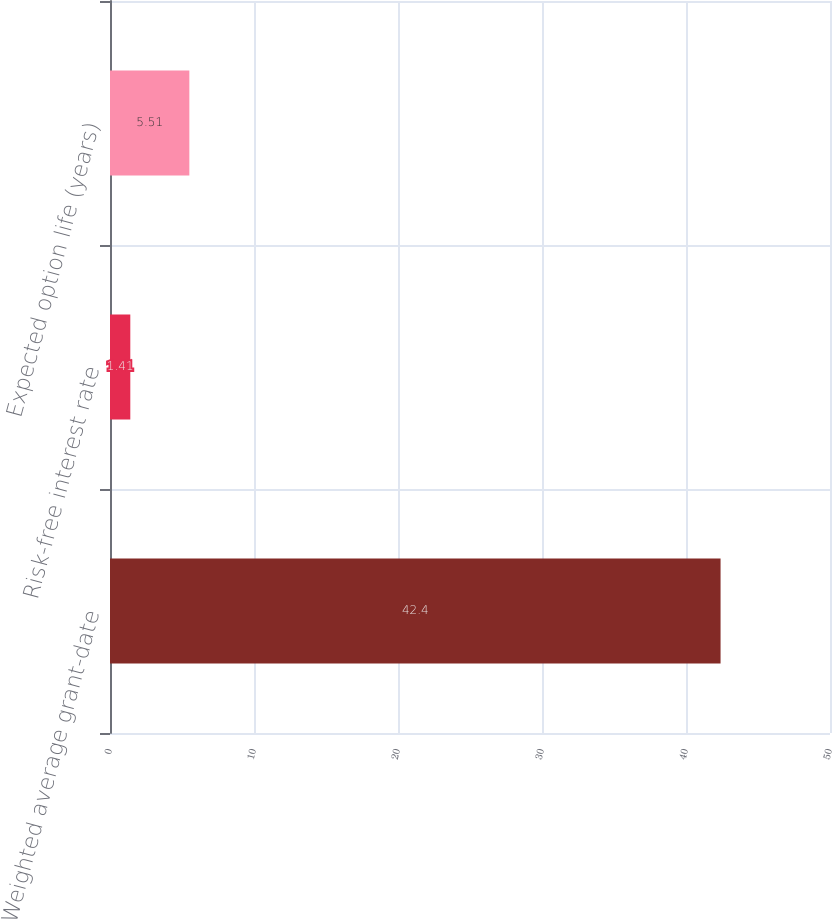Convert chart. <chart><loc_0><loc_0><loc_500><loc_500><bar_chart><fcel>Weighted average grant-date<fcel>Risk-free interest rate<fcel>Expected option life (years)<nl><fcel>42.4<fcel>1.41<fcel>5.51<nl></chart> 